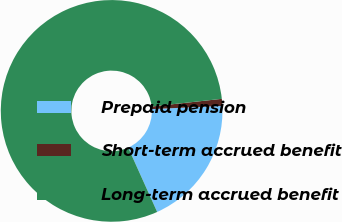Convert chart to OTSL. <chart><loc_0><loc_0><loc_500><loc_500><pie_chart><fcel>Prepaid pension<fcel>Short-term accrued benefit<fcel>Long-term accrued benefit<nl><fcel>18.98%<fcel>1.02%<fcel>80.0%<nl></chart> 